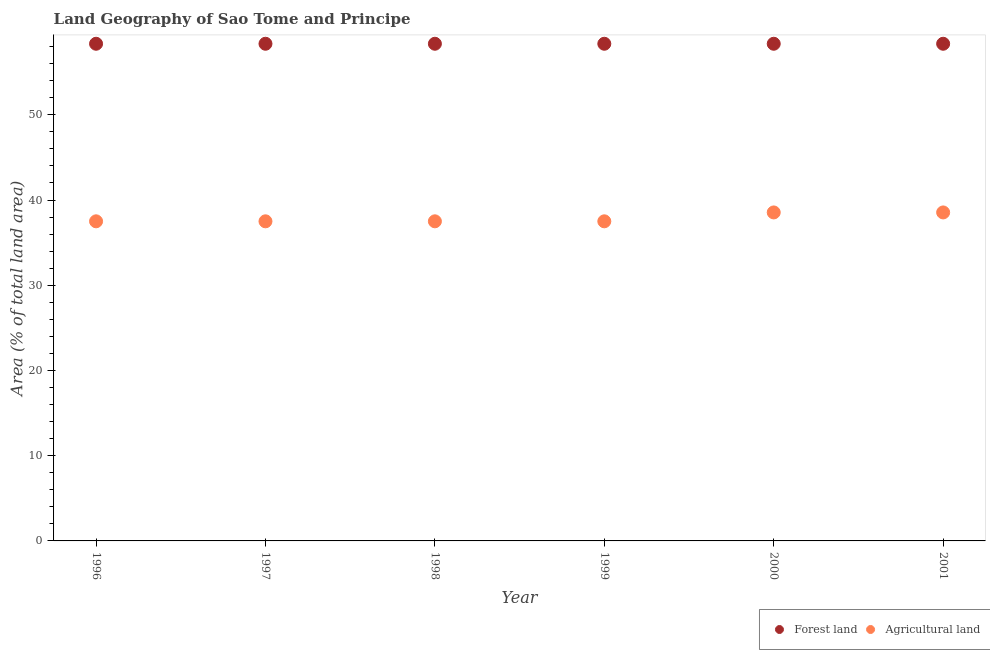Is the number of dotlines equal to the number of legend labels?
Provide a succinct answer. Yes. What is the percentage of land area under agriculture in 2001?
Your response must be concise. 38.54. Across all years, what is the maximum percentage of land area under forests?
Provide a succinct answer. 58.33. Across all years, what is the minimum percentage of land area under agriculture?
Provide a short and direct response. 37.5. In which year was the percentage of land area under agriculture minimum?
Ensure brevity in your answer.  1996. What is the total percentage of land area under agriculture in the graph?
Provide a succinct answer. 227.08. What is the difference between the percentage of land area under agriculture in 2000 and the percentage of land area under forests in 1996?
Your response must be concise. -19.79. What is the average percentage of land area under forests per year?
Keep it short and to the point. 58.33. In the year 1999, what is the difference between the percentage of land area under forests and percentage of land area under agriculture?
Keep it short and to the point. 20.83. In how many years, is the percentage of land area under forests greater than 16 %?
Make the answer very short. 6. What is the ratio of the percentage of land area under agriculture in 2000 to that in 2001?
Offer a terse response. 1. Is the percentage of land area under forests in 1997 less than that in 2000?
Offer a terse response. No. What is the difference between the highest and the second highest percentage of land area under agriculture?
Provide a succinct answer. 0. In how many years, is the percentage of land area under agriculture greater than the average percentage of land area under agriculture taken over all years?
Keep it short and to the point. 2. How many dotlines are there?
Your answer should be very brief. 2. Are the values on the major ticks of Y-axis written in scientific E-notation?
Provide a short and direct response. No. Does the graph contain grids?
Your answer should be compact. No. Where does the legend appear in the graph?
Provide a succinct answer. Bottom right. What is the title of the graph?
Ensure brevity in your answer.  Land Geography of Sao Tome and Principe. Does "Lower secondary education" appear as one of the legend labels in the graph?
Give a very brief answer. No. What is the label or title of the Y-axis?
Make the answer very short. Area (% of total land area). What is the Area (% of total land area) of Forest land in 1996?
Ensure brevity in your answer.  58.33. What is the Area (% of total land area) of Agricultural land in 1996?
Offer a terse response. 37.5. What is the Area (% of total land area) of Forest land in 1997?
Your response must be concise. 58.33. What is the Area (% of total land area) of Agricultural land in 1997?
Ensure brevity in your answer.  37.5. What is the Area (% of total land area) in Forest land in 1998?
Your answer should be very brief. 58.33. What is the Area (% of total land area) of Agricultural land in 1998?
Ensure brevity in your answer.  37.5. What is the Area (% of total land area) of Forest land in 1999?
Your response must be concise. 58.33. What is the Area (% of total land area) of Agricultural land in 1999?
Provide a succinct answer. 37.5. What is the Area (% of total land area) of Forest land in 2000?
Ensure brevity in your answer.  58.33. What is the Area (% of total land area) in Agricultural land in 2000?
Give a very brief answer. 38.54. What is the Area (% of total land area) in Forest land in 2001?
Make the answer very short. 58.33. What is the Area (% of total land area) of Agricultural land in 2001?
Keep it short and to the point. 38.54. Across all years, what is the maximum Area (% of total land area) in Forest land?
Make the answer very short. 58.33. Across all years, what is the maximum Area (% of total land area) in Agricultural land?
Make the answer very short. 38.54. Across all years, what is the minimum Area (% of total land area) in Forest land?
Your answer should be compact. 58.33. Across all years, what is the minimum Area (% of total land area) in Agricultural land?
Make the answer very short. 37.5. What is the total Area (% of total land area) in Forest land in the graph?
Offer a very short reply. 350. What is the total Area (% of total land area) in Agricultural land in the graph?
Your response must be concise. 227.08. What is the difference between the Area (% of total land area) of Forest land in 1996 and that in 1997?
Provide a succinct answer. 0. What is the difference between the Area (% of total land area) of Agricultural land in 1996 and that in 1997?
Keep it short and to the point. 0. What is the difference between the Area (% of total land area) of Agricultural land in 1996 and that in 1998?
Your answer should be compact. 0. What is the difference between the Area (% of total land area) of Forest land in 1996 and that in 2000?
Your answer should be compact. 0. What is the difference between the Area (% of total land area) in Agricultural land in 1996 and that in 2000?
Make the answer very short. -1.04. What is the difference between the Area (% of total land area) of Agricultural land in 1996 and that in 2001?
Offer a terse response. -1.04. What is the difference between the Area (% of total land area) in Agricultural land in 1997 and that in 1998?
Your answer should be compact. 0. What is the difference between the Area (% of total land area) in Forest land in 1997 and that in 1999?
Your response must be concise. 0. What is the difference between the Area (% of total land area) in Forest land in 1997 and that in 2000?
Provide a short and direct response. 0. What is the difference between the Area (% of total land area) in Agricultural land in 1997 and that in 2000?
Give a very brief answer. -1.04. What is the difference between the Area (% of total land area) in Forest land in 1997 and that in 2001?
Give a very brief answer. 0. What is the difference between the Area (% of total land area) of Agricultural land in 1997 and that in 2001?
Keep it short and to the point. -1.04. What is the difference between the Area (% of total land area) in Agricultural land in 1998 and that in 1999?
Provide a succinct answer. 0. What is the difference between the Area (% of total land area) in Agricultural land in 1998 and that in 2000?
Your answer should be very brief. -1.04. What is the difference between the Area (% of total land area) in Agricultural land in 1998 and that in 2001?
Make the answer very short. -1.04. What is the difference between the Area (% of total land area) in Agricultural land in 1999 and that in 2000?
Provide a succinct answer. -1.04. What is the difference between the Area (% of total land area) of Forest land in 1999 and that in 2001?
Your answer should be compact. 0. What is the difference between the Area (% of total land area) in Agricultural land in 1999 and that in 2001?
Your response must be concise. -1.04. What is the difference between the Area (% of total land area) in Agricultural land in 2000 and that in 2001?
Offer a very short reply. 0. What is the difference between the Area (% of total land area) of Forest land in 1996 and the Area (% of total land area) of Agricultural land in 1997?
Ensure brevity in your answer.  20.83. What is the difference between the Area (% of total land area) in Forest land in 1996 and the Area (% of total land area) in Agricultural land in 1998?
Provide a short and direct response. 20.83. What is the difference between the Area (% of total land area) of Forest land in 1996 and the Area (% of total land area) of Agricultural land in 1999?
Give a very brief answer. 20.83. What is the difference between the Area (% of total land area) of Forest land in 1996 and the Area (% of total land area) of Agricultural land in 2000?
Ensure brevity in your answer.  19.79. What is the difference between the Area (% of total land area) in Forest land in 1996 and the Area (% of total land area) in Agricultural land in 2001?
Give a very brief answer. 19.79. What is the difference between the Area (% of total land area) of Forest land in 1997 and the Area (% of total land area) of Agricultural land in 1998?
Provide a short and direct response. 20.83. What is the difference between the Area (% of total land area) of Forest land in 1997 and the Area (% of total land area) of Agricultural land in 1999?
Your answer should be very brief. 20.83. What is the difference between the Area (% of total land area) of Forest land in 1997 and the Area (% of total land area) of Agricultural land in 2000?
Give a very brief answer. 19.79. What is the difference between the Area (% of total land area) in Forest land in 1997 and the Area (% of total land area) in Agricultural land in 2001?
Offer a very short reply. 19.79. What is the difference between the Area (% of total land area) in Forest land in 1998 and the Area (% of total land area) in Agricultural land in 1999?
Your answer should be compact. 20.83. What is the difference between the Area (% of total land area) in Forest land in 1998 and the Area (% of total land area) in Agricultural land in 2000?
Provide a short and direct response. 19.79. What is the difference between the Area (% of total land area) in Forest land in 1998 and the Area (% of total land area) in Agricultural land in 2001?
Your answer should be very brief. 19.79. What is the difference between the Area (% of total land area) of Forest land in 1999 and the Area (% of total land area) of Agricultural land in 2000?
Your response must be concise. 19.79. What is the difference between the Area (% of total land area) in Forest land in 1999 and the Area (% of total land area) in Agricultural land in 2001?
Make the answer very short. 19.79. What is the difference between the Area (% of total land area) in Forest land in 2000 and the Area (% of total land area) in Agricultural land in 2001?
Offer a terse response. 19.79. What is the average Area (% of total land area) of Forest land per year?
Provide a succinct answer. 58.33. What is the average Area (% of total land area) of Agricultural land per year?
Make the answer very short. 37.85. In the year 1996, what is the difference between the Area (% of total land area) in Forest land and Area (% of total land area) in Agricultural land?
Give a very brief answer. 20.83. In the year 1997, what is the difference between the Area (% of total land area) in Forest land and Area (% of total land area) in Agricultural land?
Provide a succinct answer. 20.83. In the year 1998, what is the difference between the Area (% of total land area) of Forest land and Area (% of total land area) of Agricultural land?
Give a very brief answer. 20.83. In the year 1999, what is the difference between the Area (% of total land area) of Forest land and Area (% of total land area) of Agricultural land?
Keep it short and to the point. 20.83. In the year 2000, what is the difference between the Area (% of total land area) in Forest land and Area (% of total land area) in Agricultural land?
Offer a terse response. 19.79. In the year 2001, what is the difference between the Area (% of total land area) of Forest land and Area (% of total land area) of Agricultural land?
Make the answer very short. 19.79. What is the ratio of the Area (% of total land area) in Forest land in 1996 to that in 1997?
Ensure brevity in your answer.  1. What is the ratio of the Area (% of total land area) in Agricultural land in 1996 to that in 1997?
Your answer should be very brief. 1. What is the ratio of the Area (% of total land area) in Forest land in 1996 to that in 1998?
Keep it short and to the point. 1. What is the ratio of the Area (% of total land area) of Agricultural land in 1996 to that in 1999?
Your answer should be compact. 1. What is the ratio of the Area (% of total land area) in Forest land in 1996 to that in 2001?
Make the answer very short. 1. What is the ratio of the Area (% of total land area) in Forest land in 1997 to that in 1998?
Ensure brevity in your answer.  1. What is the ratio of the Area (% of total land area) of Agricultural land in 1997 to that in 1998?
Provide a short and direct response. 1. What is the ratio of the Area (% of total land area) of Forest land in 1997 to that in 1999?
Your answer should be very brief. 1. What is the ratio of the Area (% of total land area) of Agricultural land in 1997 to that in 1999?
Provide a short and direct response. 1. What is the ratio of the Area (% of total land area) in Agricultural land in 1997 to that in 2000?
Your answer should be compact. 0.97. What is the ratio of the Area (% of total land area) of Forest land in 1998 to that in 1999?
Give a very brief answer. 1. What is the ratio of the Area (% of total land area) of Agricultural land in 1998 to that in 1999?
Keep it short and to the point. 1. What is the ratio of the Area (% of total land area) in Forest land in 1998 to that in 2000?
Keep it short and to the point. 1. What is the ratio of the Area (% of total land area) of Forest land in 1999 to that in 2000?
Provide a short and direct response. 1. What is the ratio of the Area (% of total land area) in Forest land in 1999 to that in 2001?
Provide a short and direct response. 1. What is the ratio of the Area (% of total land area) in Agricultural land in 2000 to that in 2001?
Provide a succinct answer. 1. What is the difference between the highest and the lowest Area (% of total land area) in Forest land?
Offer a very short reply. 0. What is the difference between the highest and the lowest Area (% of total land area) of Agricultural land?
Provide a short and direct response. 1.04. 